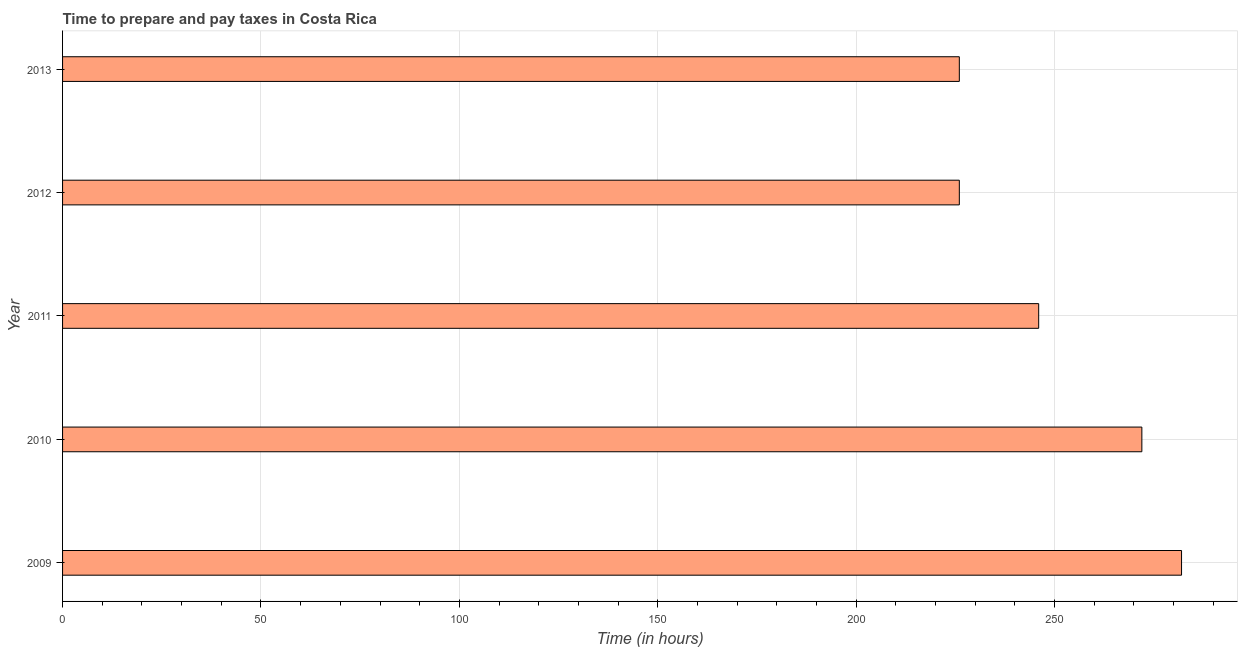Does the graph contain any zero values?
Provide a short and direct response. No. Does the graph contain grids?
Your answer should be very brief. Yes. What is the title of the graph?
Offer a very short reply. Time to prepare and pay taxes in Costa Rica. What is the label or title of the X-axis?
Ensure brevity in your answer.  Time (in hours). What is the time to prepare and pay taxes in 2013?
Provide a succinct answer. 226. Across all years, what is the maximum time to prepare and pay taxes?
Keep it short and to the point. 282. Across all years, what is the minimum time to prepare and pay taxes?
Make the answer very short. 226. In which year was the time to prepare and pay taxes minimum?
Your answer should be compact. 2012. What is the sum of the time to prepare and pay taxes?
Offer a terse response. 1252. What is the difference between the time to prepare and pay taxes in 2011 and 2012?
Your answer should be compact. 20. What is the average time to prepare and pay taxes per year?
Ensure brevity in your answer.  250. What is the median time to prepare and pay taxes?
Give a very brief answer. 246. Do a majority of the years between 2011 and 2010 (inclusive) have time to prepare and pay taxes greater than 130 hours?
Provide a succinct answer. No. What is the ratio of the time to prepare and pay taxes in 2010 to that in 2013?
Your answer should be very brief. 1.2. Is the time to prepare and pay taxes in 2012 less than that in 2013?
Provide a succinct answer. No. What is the difference between the highest and the second highest time to prepare and pay taxes?
Keep it short and to the point. 10. What is the difference between the highest and the lowest time to prepare and pay taxes?
Your answer should be very brief. 56. Are all the bars in the graph horizontal?
Offer a terse response. Yes. How many years are there in the graph?
Ensure brevity in your answer.  5. What is the Time (in hours) of 2009?
Ensure brevity in your answer.  282. What is the Time (in hours) of 2010?
Offer a terse response. 272. What is the Time (in hours) of 2011?
Provide a succinct answer. 246. What is the Time (in hours) of 2012?
Your answer should be very brief. 226. What is the Time (in hours) of 2013?
Make the answer very short. 226. What is the difference between the Time (in hours) in 2009 and 2011?
Make the answer very short. 36. What is the difference between the Time (in hours) in 2009 and 2013?
Give a very brief answer. 56. What is the difference between the Time (in hours) in 2010 and 2012?
Offer a terse response. 46. What is the difference between the Time (in hours) in 2010 and 2013?
Provide a succinct answer. 46. What is the difference between the Time (in hours) in 2011 and 2012?
Keep it short and to the point. 20. What is the difference between the Time (in hours) in 2012 and 2013?
Provide a short and direct response. 0. What is the ratio of the Time (in hours) in 2009 to that in 2011?
Provide a succinct answer. 1.15. What is the ratio of the Time (in hours) in 2009 to that in 2012?
Provide a succinct answer. 1.25. What is the ratio of the Time (in hours) in 2009 to that in 2013?
Provide a short and direct response. 1.25. What is the ratio of the Time (in hours) in 2010 to that in 2011?
Offer a very short reply. 1.11. What is the ratio of the Time (in hours) in 2010 to that in 2012?
Your response must be concise. 1.2. What is the ratio of the Time (in hours) in 2010 to that in 2013?
Your answer should be very brief. 1.2. What is the ratio of the Time (in hours) in 2011 to that in 2012?
Make the answer very short. 1.09. What is the ratio of the Time (in hours) in 2011 to that in 2013?
Ensure brevity in your answer.  1.09. What is the ratio of the Time (in hours) in 2012 to that in 2013?
Your response must be concise. 1. 